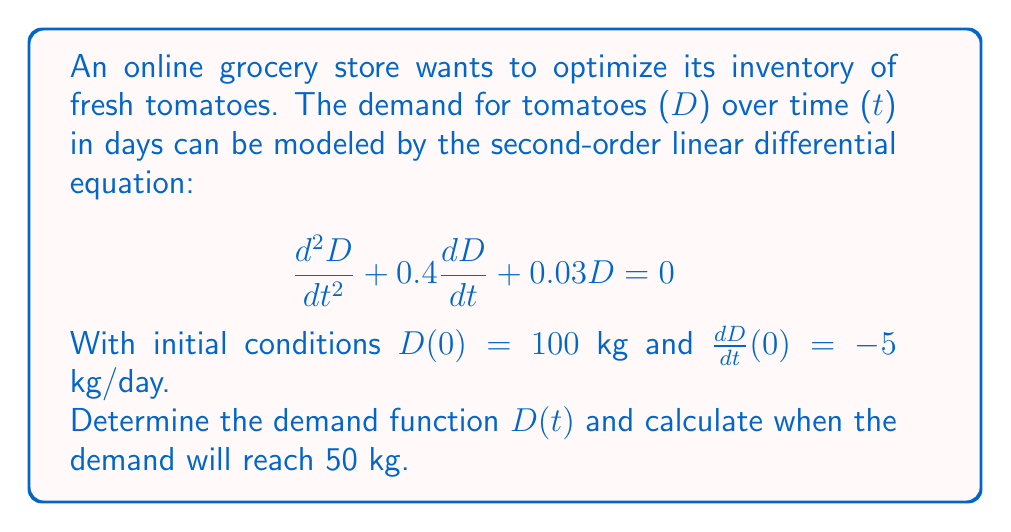Give your solution to this math problem. 1) The characteristic equation for this differential equation is:
   $$r^2 + 0.4r + 0.03 = 0$$

2) Solving this quadratic equation:
   $$r = \frac{-0.4 \pm \sqrt{0.4^2 - 4(1)(0.03)}}{2(1)} = \frac{-0.4 \pm \sqrt{0.16 - 0.12}}{2} = \frac{-0.4 \pm 0.2}{2}$$

3) This gives us two roots:
   $$r_1 = -0.3 \text{ and } r_2 = -0.1$$

4) The general solution is therefore:
   $$D(t) = C_1e^{-0.3t} + C_2e^{-0.1t}$$

5) Using the initial condition $D(0) = 100$:
   $$100 = C_1 + C_2$$

6) Taking the derivative:
   $$\frac{dD}{dt} = -0.3C_1e^{-0.3t} - 0.1C_2e^{-0.1t}$$

7) Using the second initial condition $\frac{dD}{dt}(0) = -5$:
   $$-5 = -0.3C_1 - 0.1C_2$$

8) Solving these simultaneous equations:
   $$C_1 = 75 \text{ and } C_2 = 25$$

9) Therefore, the demand function is:
   $$D(t) = 75e^{-0.3t} + 25e^{-0.1t}$$

10) To find when demand reaches 50 kg, solve:
    $$50 = 75e^{-0.3t} + 25e^{-0.1t}$$

11) This transcendental equation can be solved numerically, giving:
    $$t \approx 13.86 \text{ days}$$
Answer: $D(t) = 75e^{-0.3t} + 25e^{-0.1t}$; Demand reaches 50 kg after 13.86 days 